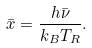<formula> <loc_0><loc_0><loc_500><loc_500>\bar { x } = \frac { h \bar { \nu } } { k _ { B } T _ { R } } .</formula> 